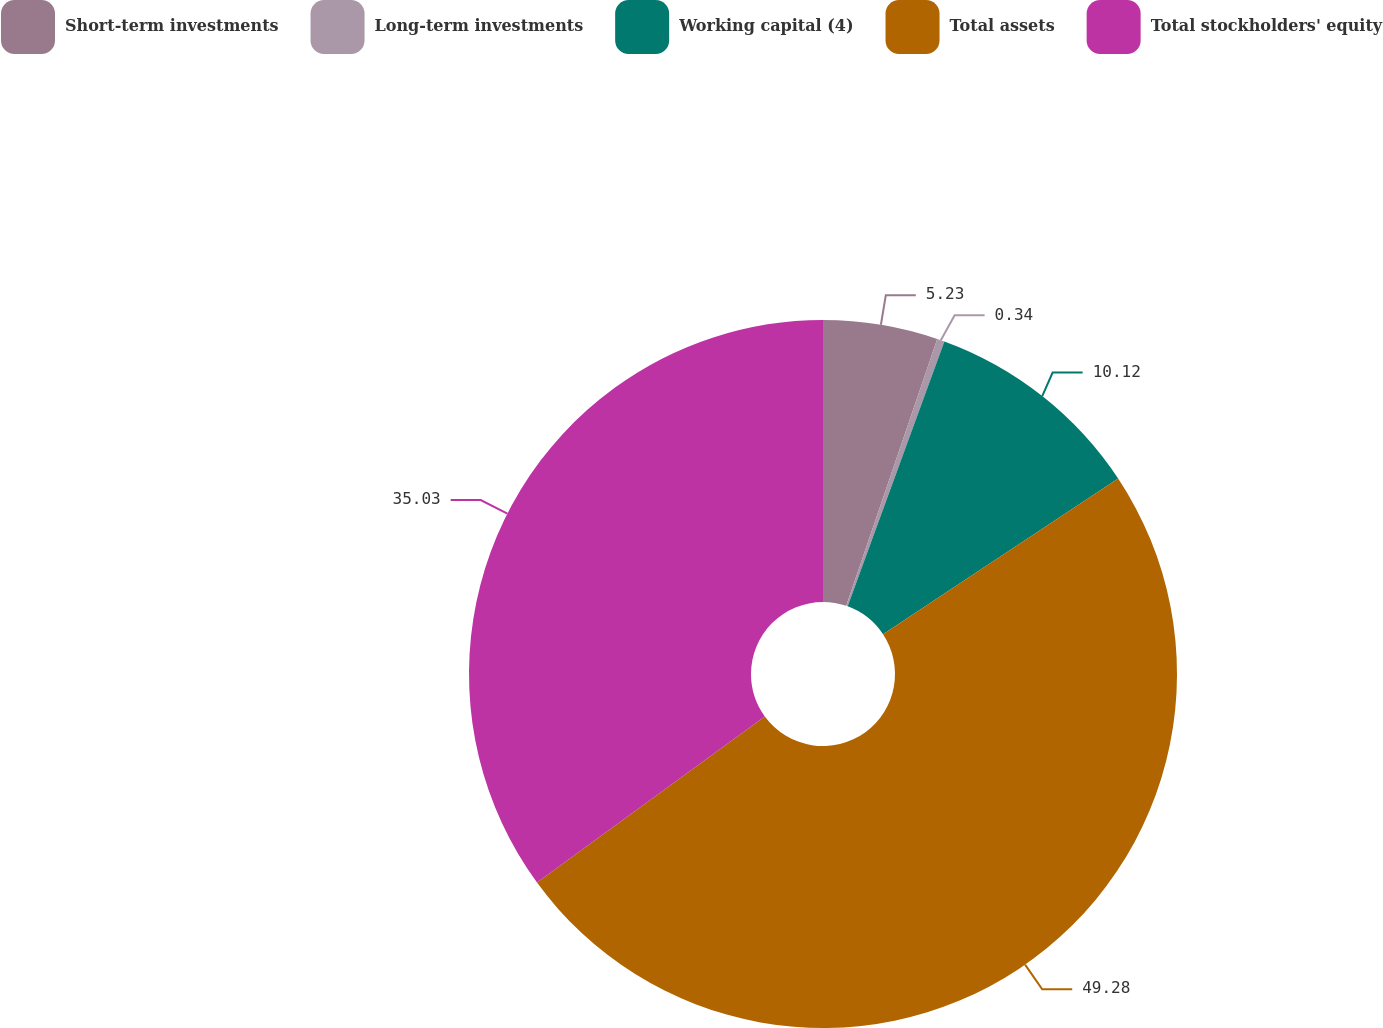Convert chart to OTSL. <chart><loc_0><loc_0><loc_500><loc_500><pie_chart><fcel>Short-term investments<fcel>Long-term investments<fcel>Working capital (4)<fcel>Total assets<fcel>Total stockholders' equity<nl><fcel>5.23%<fcel>0.34%<fcel>10.12%<fcel>49.28%<fcel>35.03%<nl></chart> 